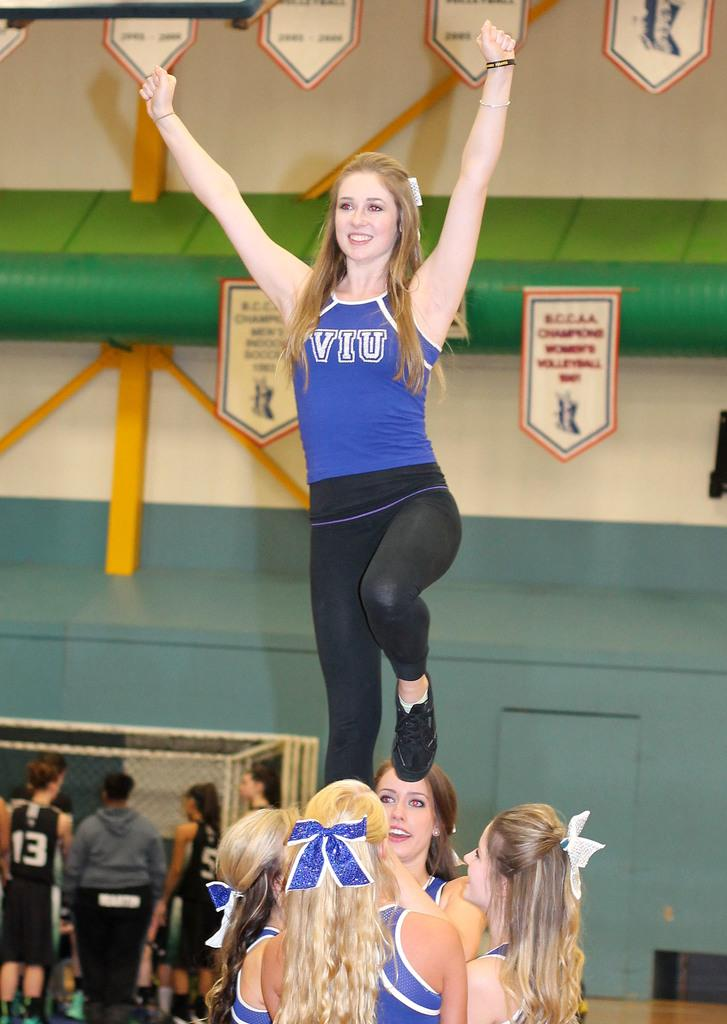<image>
Relay a brief, clear account of the picture shown. Cheerleader wearing a purple shirt that says VIU. 